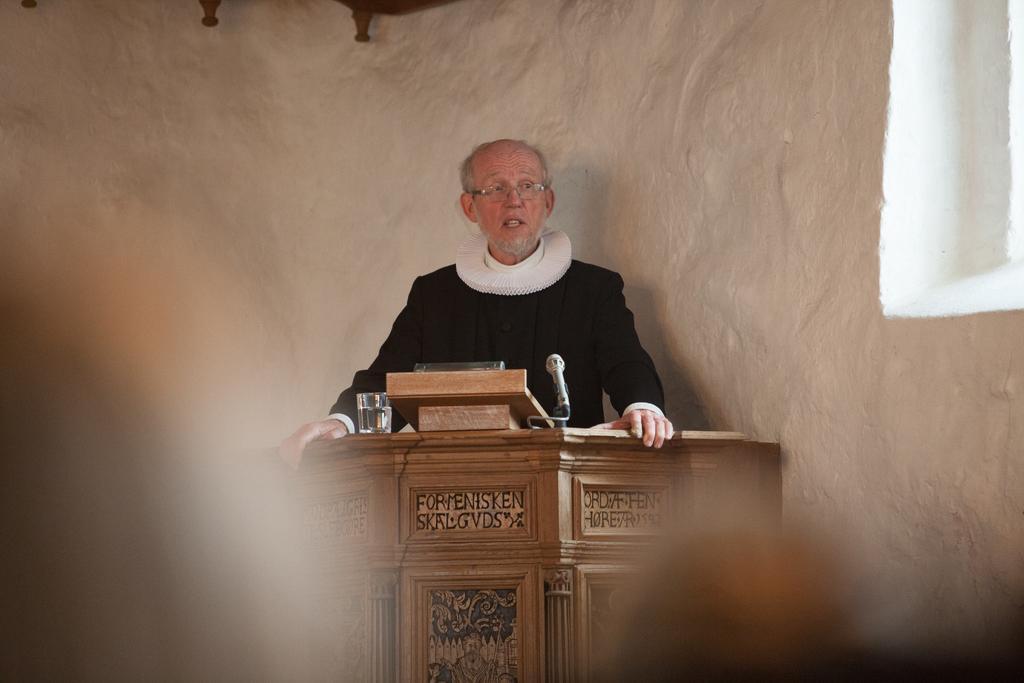In one or two sentences, can you explain what this image depicts? In this image we can see one man standing near to the podium and holding it. There is some text on the wooden podium, one water glass, one mike, and some objects are on the podium. There is one white big wall back side of the person and one object hanged to the wall. Some people heads near to the podium. 